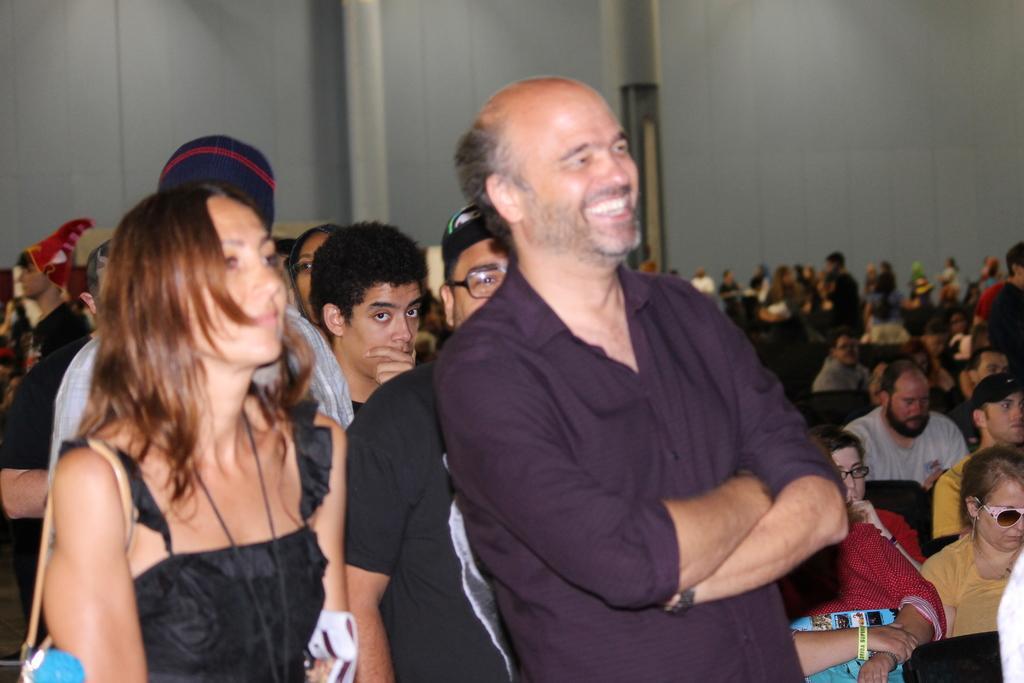In one or two sentences, can you explain what this image depicts? In this image, we can see a few people. Among them, some people are sitting. We can also see the walls. 